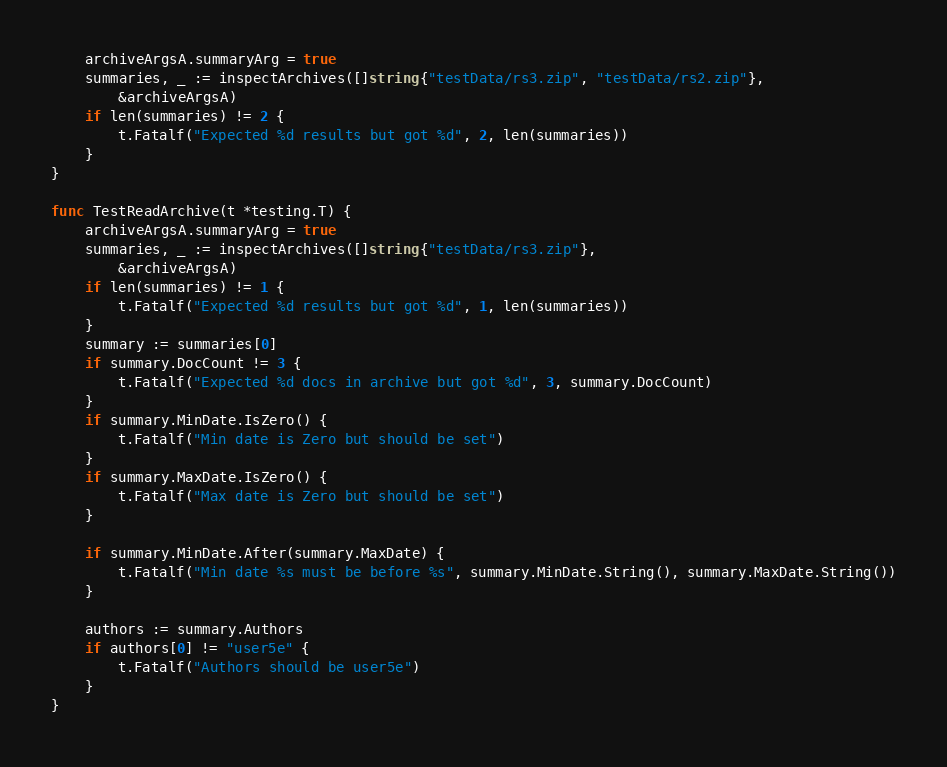<code> <loc_0><loc_0><loc_500><loc_500><_Go_>	archiveArgsA.summaryArg = true
	summaries, _ := inspectArchives([]string{"testData/rs3.zip", "testData/rs2.zip"},
		&archiveArgsA)
	if len(summaries) != 2 {
		t.Fatalf("Expected %d results but got %d", 2, len(summaries))
	}
}

func TestReadArchive(t *testing.T) {
	archiveArgsA.summaryArg = true
	summaries, _ := inspectArchives([]string{"testData/rs3.zip"},
		&archiveArgsA)
	if len(summaries) != 1 {
		t.Fatalf("Expected %d results but got %d", 1, len(summaries))
	}
	summary := summaries[0]
	if summary.DocCount != 3 {
		t.Fatalf("Expected %d docs in archive but got %d", 3, summary.DocCount)
	}
	if summary.MinDate.IsZero() {
		t.Fatalf("Min date is Zero but should be set")
	}
	if summary.MaxDate.IsZero() {
		t.Fatalf("Max date is Zero but should be set")
	}

	if summary.MinDate.After(summary.MaxDate) {
		t.Fatalf("Min date %s must be before %s", summary.MinDate.String(), summary.MaxDate.String())
	}

	authors := summary.Authors
	if authors[0] != "user5e" {
		t.Fatalf("Authors should be user5e")
	}
}
</code> 